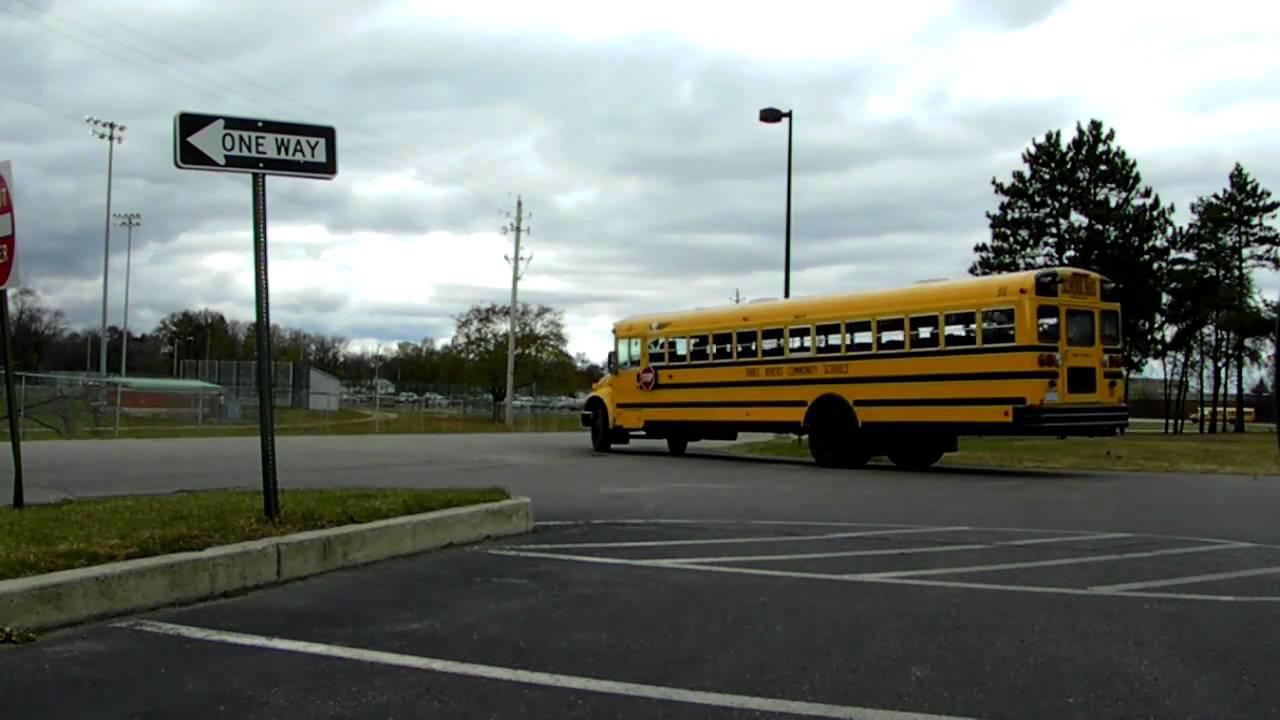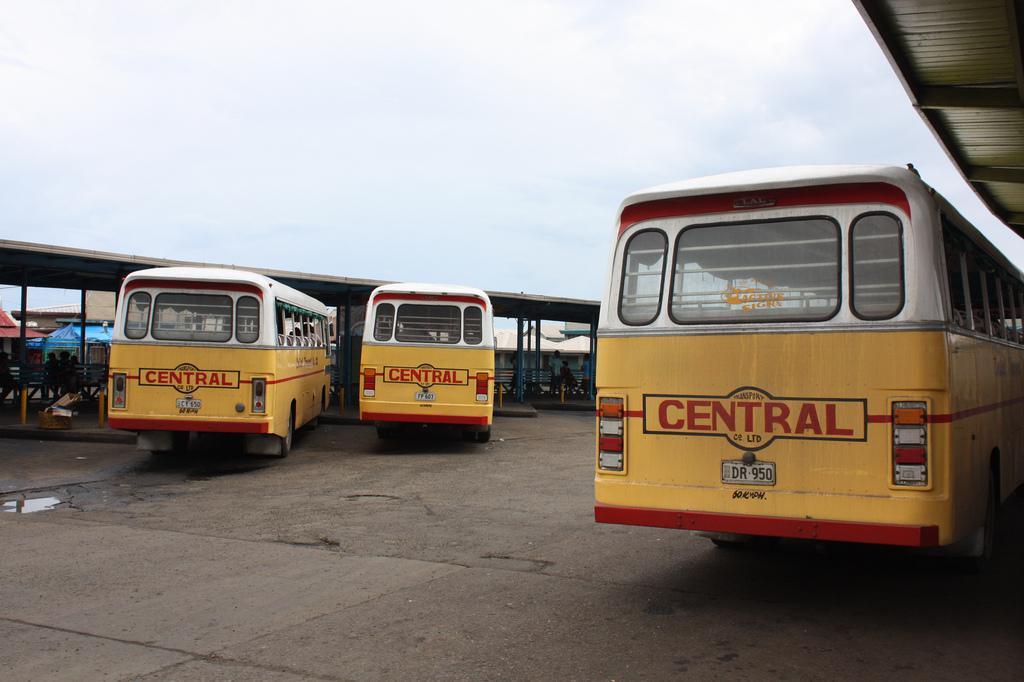The first image is the image on the left, the second image is the image on the right. Evaluate the accuracy of this statement regarding the images: "Exactly one image contains both school buses and fire trucks.". Is it true? Answer yes or no. No. The first image is the image on the left, the second image is the image on the right. Considering the images on both sides, is "In at least one image there is one parked yellow bus near one police  vehicle." valid? Answer yes or no. No. 